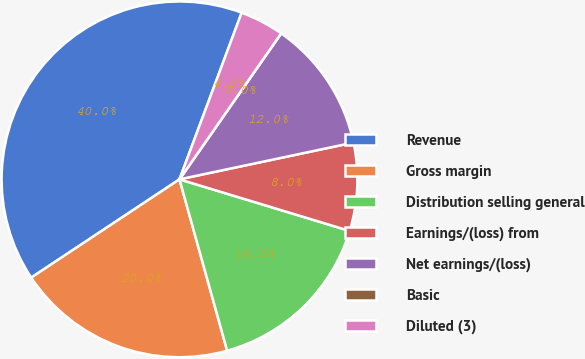Convert chart. <chart><loc_0><loc_0><loc_500><loc_500><pie_chart><fcel>Revenue<fcel>Gross margin<fcel>Distribution selling general<fcel>Earnings/(loss) from<fcel>Net earnings/(loss)<fcel>Basic<fcel>Diluted (3)<nl><fcel>40.0%<fcel>20.0%<fcel>16.0%<fcel>8.0%<fcel>12.0%<fcel>0.0%<fcel>4.0%<nl></chart> 